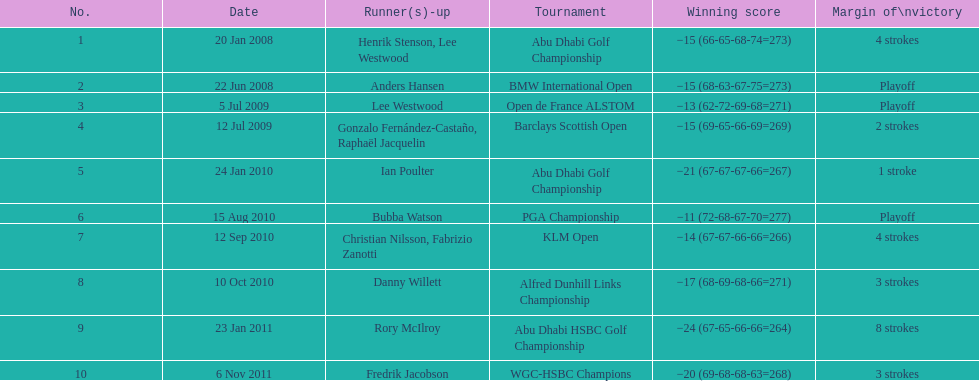How long separated the playoff victory at bmw international open and the 4 stroke victory at the klm open? 2 years. 